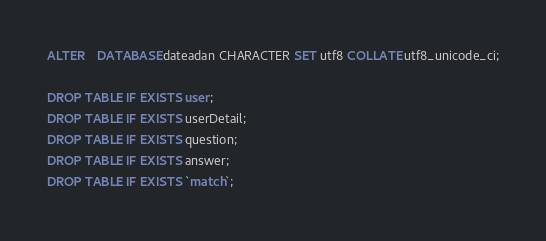<code> <loc_0><loc_0><loc_500><loc_500><_SQL_>ALTER	DATABASE dateadan CHARACTER SET utf8 COLLATE utf8_unicode_ci;

DROP TABLE IF EXISTS user;
DROP TABLE IF EXISTS userDetail;
DROP TABLE IF EXISTS question;
DROP TABLE IF EXISTS answer;
DROP TABLE IF EXISTS `match`;</code> 